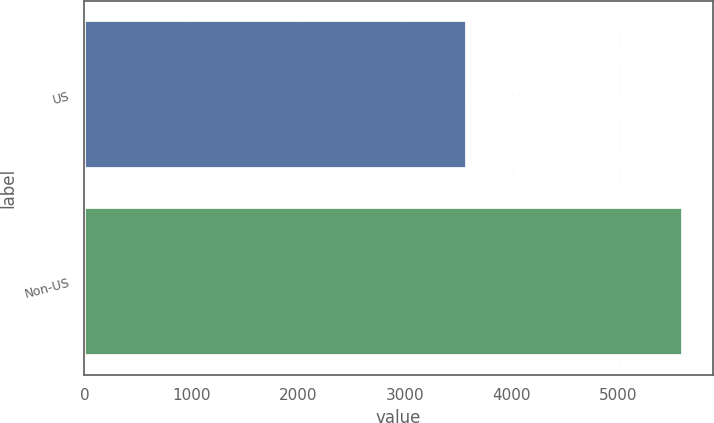Convert chart. <chart><loc_0><loc_0><loc_500><loc_500><bar_chart><fcel>US<fcel>Non-US<nl><fcel>3577<fcel>5600<nl></chart> 